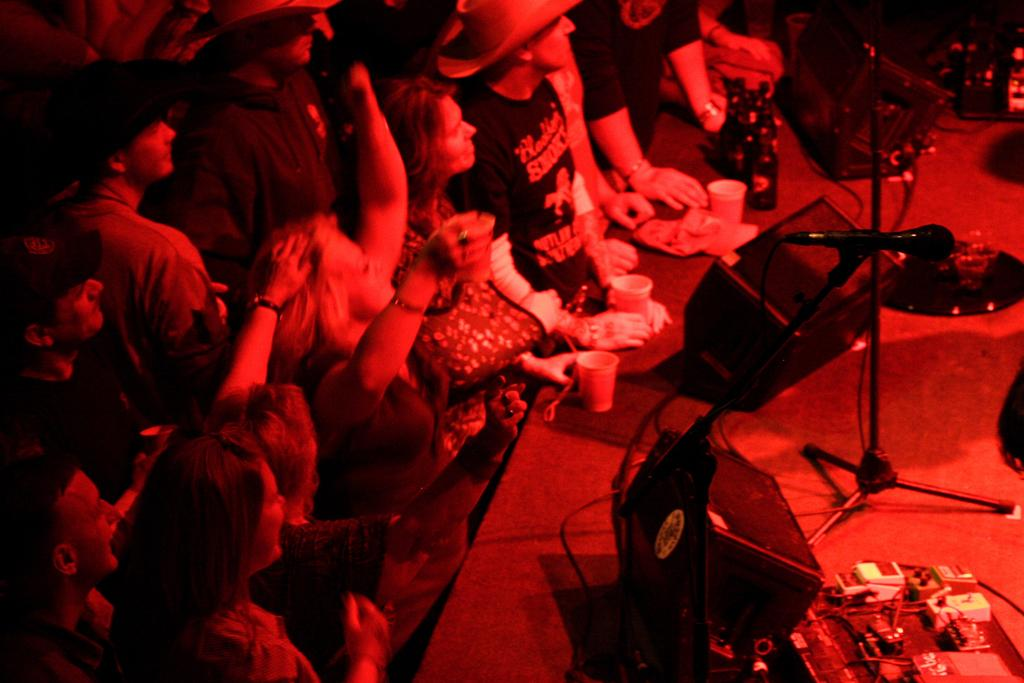What is happening on the stage in the image? There are many persons standing near the stage, and there are speakers, a mic stand, a microphone, cables, a glass, bags, and other objects on the stage. What equipment is present on the stage for amplifying sound? There are speakers and a microphone on the stage. What object might be used for holding a microphone? There is a mic stand on the stage. What type of object might be used for carrying items? There are bags on the stage. What type of caption is visible on the stage in the image? There is no caption visible on the stage in the image. Can you tell me how many appliances are present on the stage? There is no appliance present on the stage in the image. 